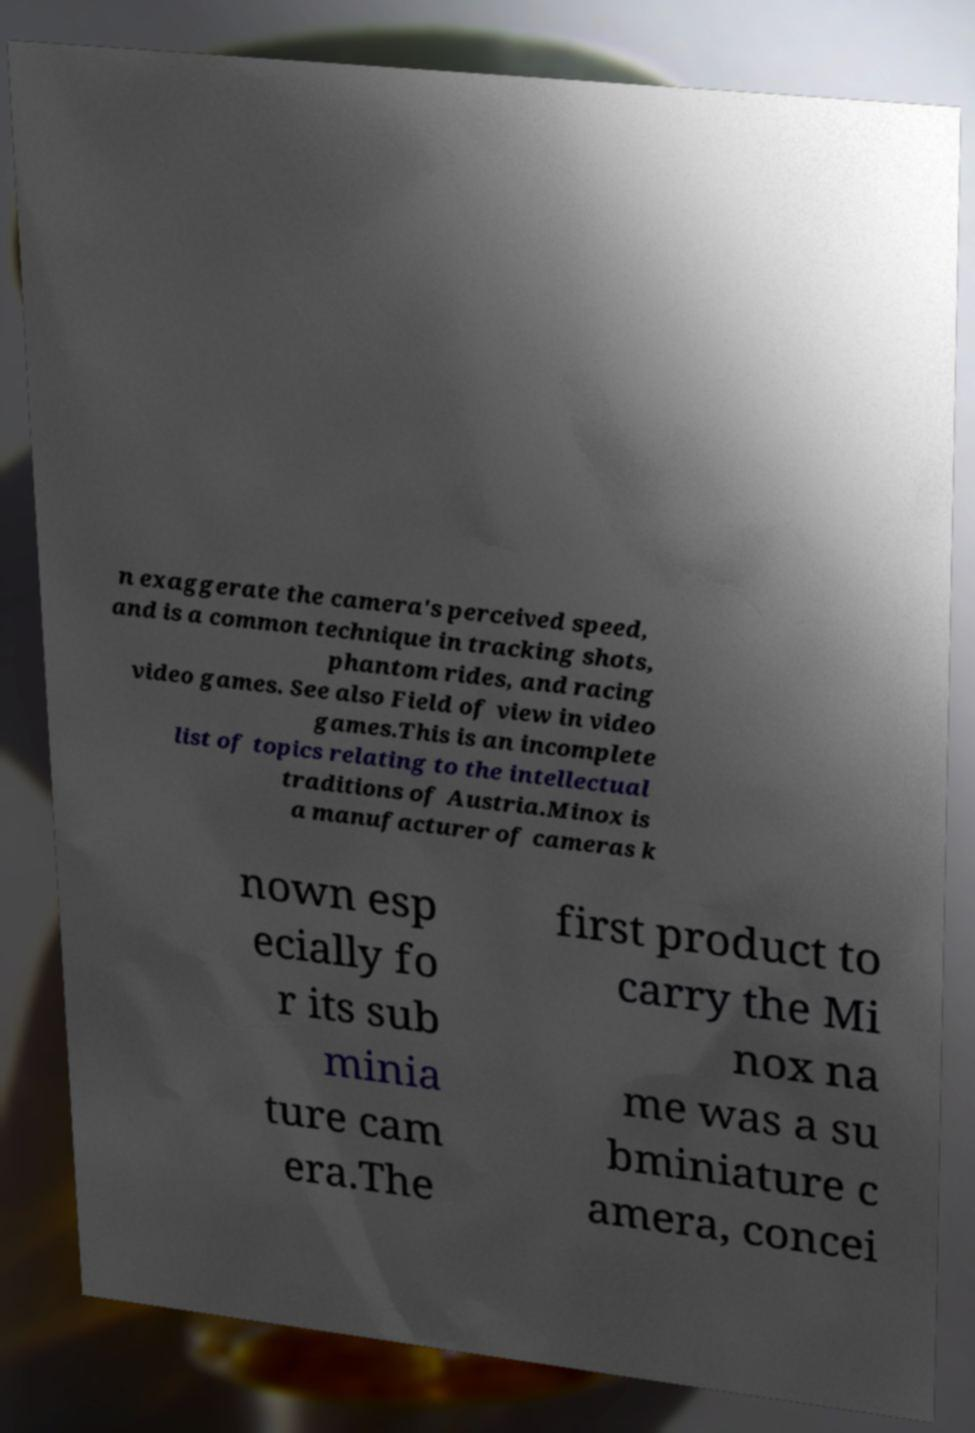Can you accurately transcribe the text from the provided image for me? n exaggerate the camera's perceived speed, and is a common technique in tracking shots, phantom rides, and racing video games. See also Field of view in video games.This is an incomplete list of topics relating to the intellectual traditions of Austria.Minox is a manufacturer of cameras k nown esp ecially fo r its sub minia ture cam era.The first product to carry the Mi nox na me was a su bminiature c amera, concei 